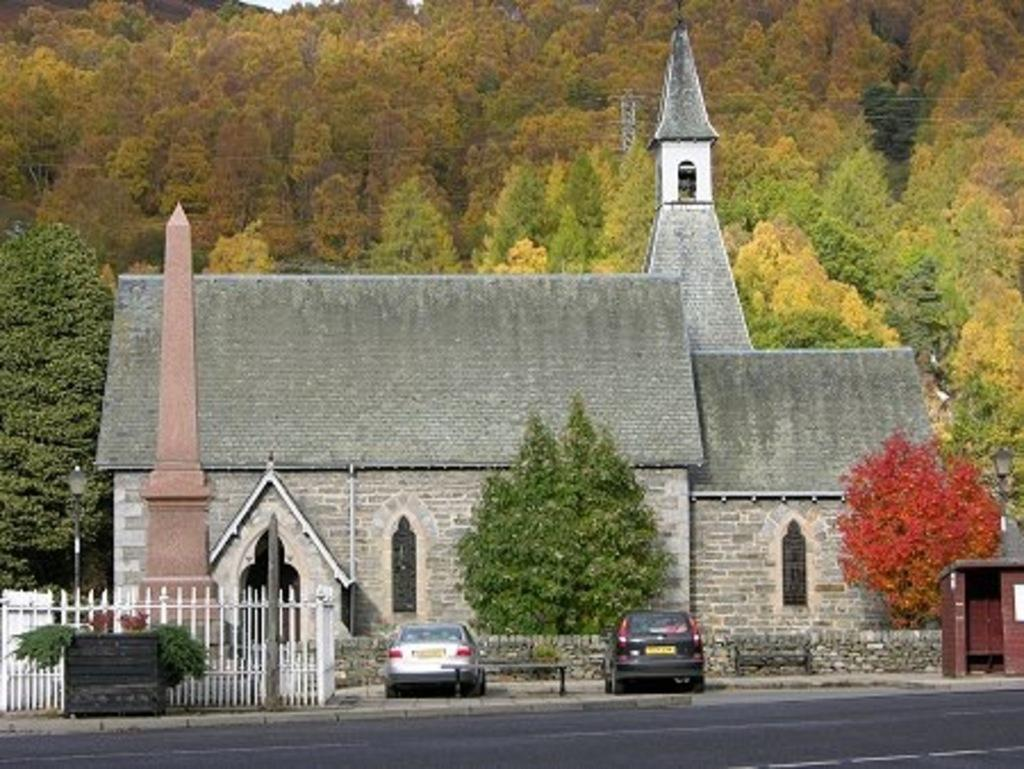What is the main structure in the picture? There is a castle in the picture. What can be seen in front of the castle? There are two vehicles and two trees in front of the castle. What is visible in the background of the picture? There are plenty of trees in the background of the picture. What advice is the castle giving to the babies in the image? There are no babies present in the image, and the castle is not capable of giving advice. 